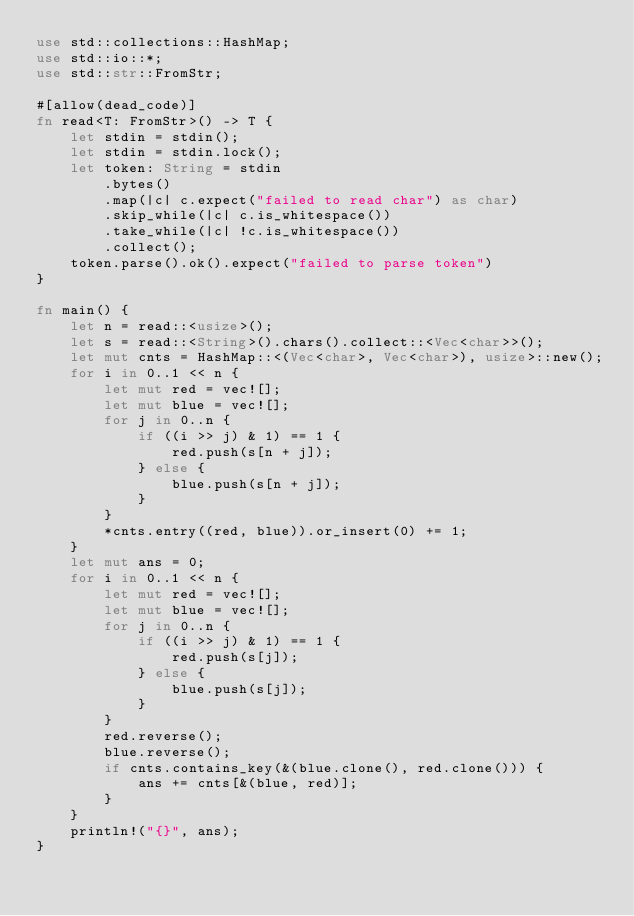<code> <loc_0><loc_0><loc_500><loc_500><_Rust_>use std::collections::HashMap;
use std::io::*;
use std::str::FromStr;

#[allow(dead_code)]
fn read<T: FromStr>() -> T {
    let stdin = stdin();
    let stdin = stdin.lock();
    let token: String = stdin
        .bytes()
        .map(|c| c.expect("failed to read char") as char)
        .skip_while(|c| c.is_whitespace())
        .take_while(|c| !c.is_whitespace())
        .collect();
    token.parse().ok().expect("failed to parse token")
}

fn main() {
    let n = read::<usize>();
    let s = read::<String>().chars().collect::<Vec<char>>();
    let mut cnts = HashMap::<(Vec<char>, Vec<char>), usize>::new();
    for i in 0..1 << n {
        let mut red = vec![];
        let mut blue = vec![];
        for j in 0..n {
            if ((i >> j) & 1) == 1 {
                red.push(s[n + j]);
            } else {
                blue.push(s[n + j]);
            }
        }
        *cnts.entry((red, blue)).or_insert(0) += 1;
    }
    let mut ans = 0;
    for i in 0..1 << n {
        let mut red = vec![];
        let mut blue = vec![];
        for j in 0..n {
            if ((i >> j) & 1) == 1 {
                red.push(s[j]);
            } else {
                blue.push(s[j]);
            }
        }
        red.reverse();
        blue.reverse();
        if cnts.contains_key(&(blue.clone(), red.clone())) {
            ans += cnts[&(blue, red)];
        }
    }
    println!("{}", ans);
}
</code> 